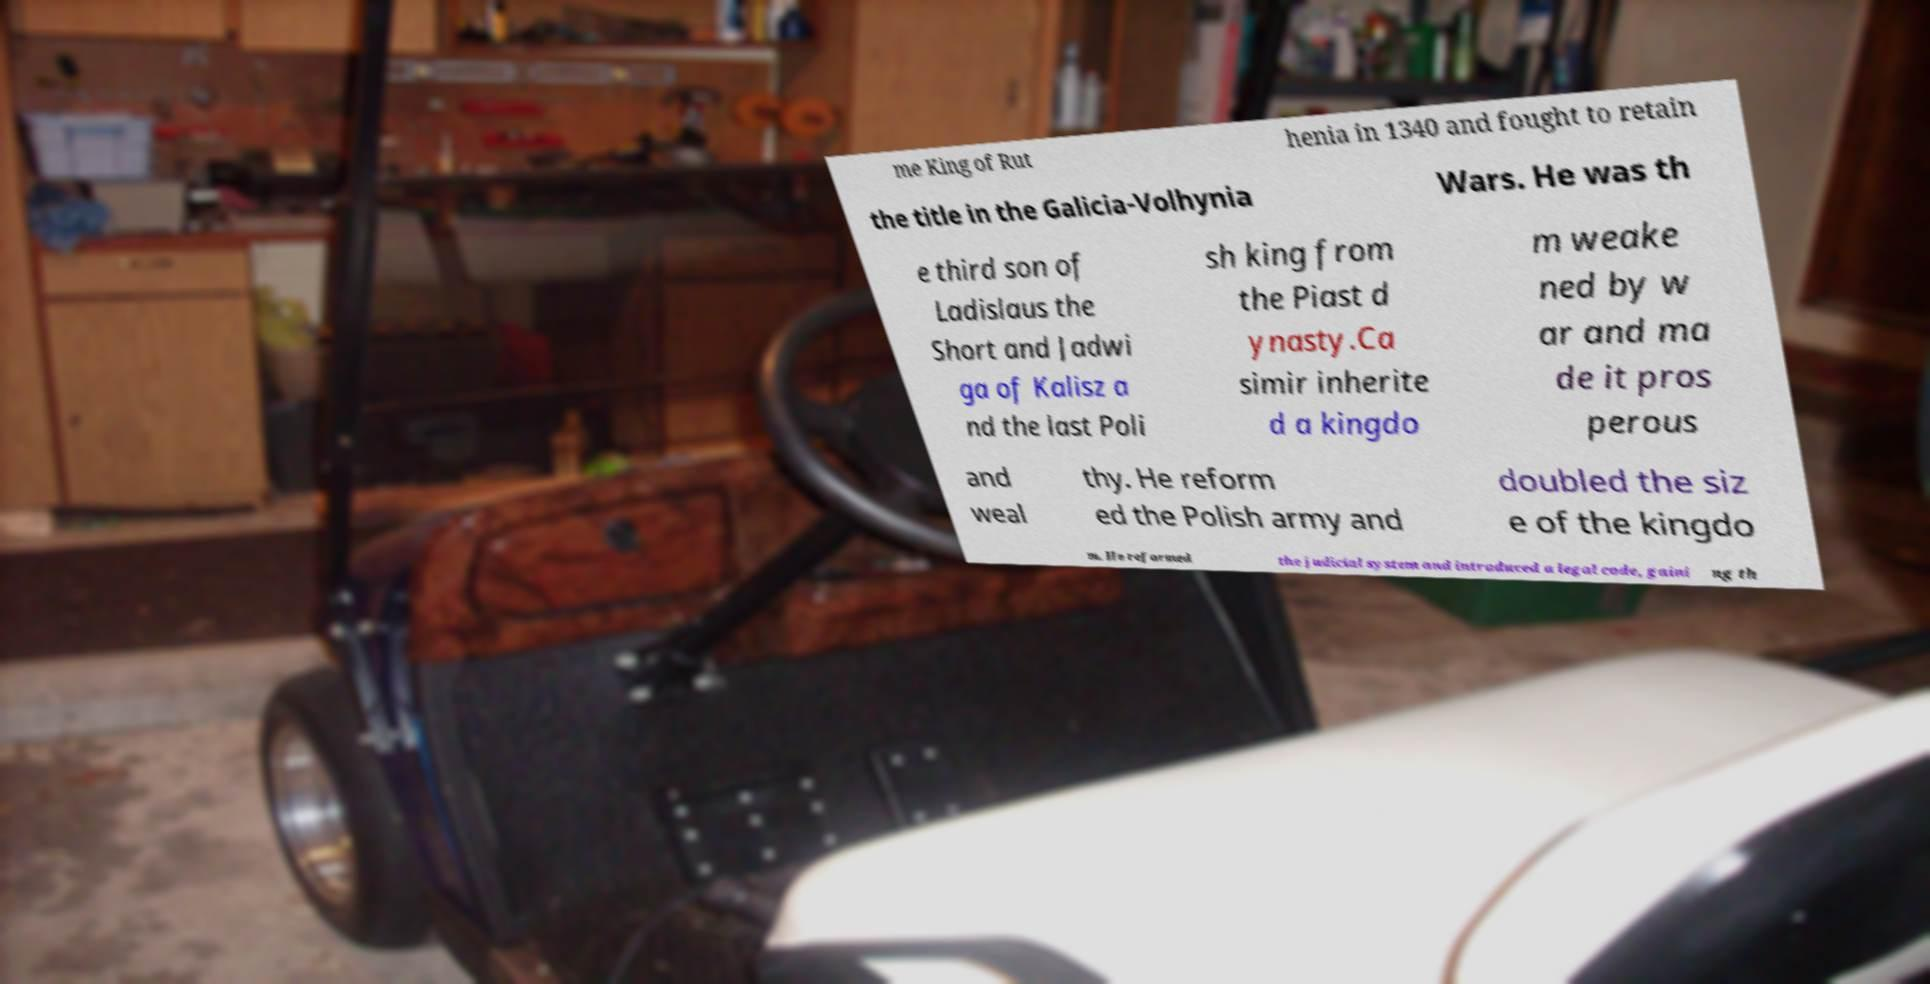Please read and relay the text visible in this image. What does it say? me King of Rut henia in 1340 and fought to retain the title in the Galicia-Volhynia Wars. He was th e third son of Ladislaus the Short and Jadwi ga of Kalisz a nd the last Poli sh king from the Piast d ynasty.Ca simir inherite d a kingdo m weake ned by w ar and ma de it pros perous and weal thy. He reform ed the Polish army and doubled the siz e of the kingdo m. He reformed the judicial system and introduced a legal code, gaini ng th 